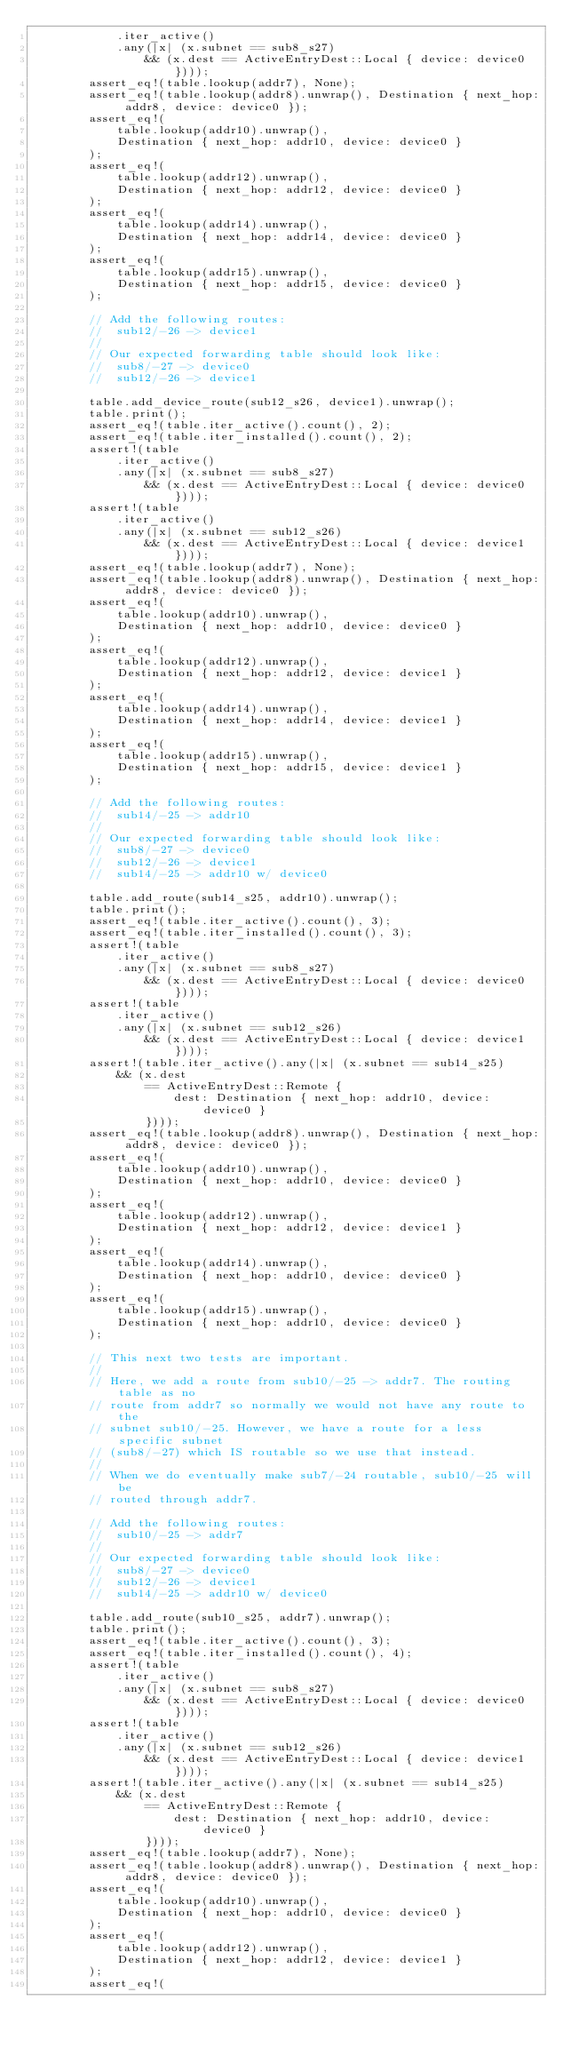Convert code to text. <code><loc_0><loc_0><loc_500><loc_500><_Rust_>            .iter_active()
            .any(|x| (x.subnet == sub8_s27)
                && (x.dest == ActiveEntryDest::Local { device: device0 })));
        assert_eq!(table.lookup(addr7), None);
        assert_eq!(table.lookup(addr8).unwrap(), Destination { next_hop: addr8, device: device0 });
        assert_eq!(
            table.lookup(addr10).unwrap(),
            Destination { next_hop: addr10, device: device0 }
        );
        assert_eq!(
            table.lookup(addr12).unwrap(),
            Destination { next_hop: addr12, device: device0 }
        );
        assert_eq!(
            table.lookup(addr14).unwrap(),
            Destination { next_hop: addr14, device: device0 }
        );
        assert_eq!(
            table.lookup(addr15).unwrap(),
            Destination { next_hop: addr15, device: device0 }
        );

        // Add the following routes:
        //  sub12/-26 -> device1
        //
        // Our expected forwarding table should look like:
        //  sub8/-27 -> device0
        //  sub12/-26 -> device1

        table.add_device_route(sub12_s26, device1).unwrap();
        table.print();
        assert_eq!(table.iter_active().count(), 2);
        assert_eq!(table.iter_installed().count(), 2);
        assert!(table
            .iter_active()
            .any(|x| (x.subnet == sub8_s27)
                && (x.dest == ActiveEntryDest::Local { device: device0 })));
        assert!(table
            .iter_active()
            .any(|x| (x.subnet == sub12_s26)
                && (x.dest == ActiveEntryDest::Local { device: device1 })));
        assert_eq!(table.lookup(addr7), None);
        assert_eq!(table.lookup(addr8).unwrap(), Destination { next_hop: addr8, device: device0 });
        assert_eq!(
            table.lookup(addr10).unwrap(),
            Destination { next_hop: addr10, device: device0 }
        );
        assert_eq!(
            table.lookup(addr12).unwrap(),
            Destination { next_hop: addr12, device: device1 }
        );
        assert_eq!(
            table.lookup(addr14).unwrap(),
            Destination { next_hop: addr14, device: device1 }
        );
        assert_eq!(
            table.lookup(addr15).unwrap(),
            Destination { next_hop: addr15, device: device1 }
        );

        // Add the following routes:
        //  sub14/-25 -> addr10
        //
        // Our expected forwarding table should look like:
        //  sub8/-27 -> device0
        //  sub12/-26 -> device1
        //  sub14/-25 -> addr10 w/ device0

        table.add_route(sub14_s25, addr10).unwrap();
        table.print();
        assert_eq!(table.iter_active().count(), 3);
        assert_eq!(table.iter_installed().count(), 3);
        assert!(table
            .iter_active()
            .any(|x| (x.subnet == sub8_s27)
                && (x.dest == ActiveEntryDest::Local { device: device0 })));
        assert!(table
            .iter_active()
            .any(|x| (x.subnet == sub12_s26)
                && (x.dest == ActiveEntryDest::Local { device: device1 })));
        assert!(table.iter_active().any(|x| (x.subnet == sub14_s25)
            && (x.dest
                == ActiveEntryDest::Remote {
                    dest: Destination { next_hop: addr10, device: device0 }
                })));
        assert_eq!(table.lookup(addr8).unwrap(), Destination { next_hop: addr8, device: device0 });
        assert_eq!(
            table.lookup(addr10).unwrap(),
            Destination { next_hop: addr10, device: device0 }
        );
        assert_eq!(
            table.lookup(addr12).unwrap(),
            Destination { next_hop: addr12, device: device1 }
        );
        assert_eq!(
            table.lookup(addr14).unwrap(),
            Destination { next_hop: addr10, device: device0 }
        );
        assert_eq!(
            table.lookup(addr15).unwrap(),
            Destination { next_hop: addr10, device: device0 }
        );

        // This next two tests are important.
        //
        // Here, we add a route from sub10/-25 -> addr7. The routing table as no
        // route from addr7 so normally we would not have any route to the
        // subnet sub10/-25. However, we have a route for a less specific subnet
        // (sub8/-27) which IS routable so we use that instead.
        //
        // When we do eventually make sub7/-24 routable, sub10/-25 will be
        // routed through addr7.

        // Add the following routes:
        //  sub10/-25 -> addr7
        //
        // Our expected forwarding table should look like:
        //  sub8/-27 -> device0
        //  sub12/-26 -> device1
        //  sub14/-25 -> addr10 w/ device0

        table.add_route(sub10_s25, addr7).unwrap();
        table.print();
        assert_eq!(table.iter_active().count(), 3);
        assert_eq!(table.iter_installed().count(), 4);
        assert!(table
            .iter_active()
            .any(|x| (x.subnet == sub8_s27)
                && (x.dest == ActiveEntryDest::Local { device: device0 })));
        assert!(table
            .iter_active()
            .any(|x| (x.subnet == sub12_s26)
                && (x.dest == ActiveEntryDest::Local { device: device1 })));
        assert!(table.iter_active().any(|x| (x.subnet == sub14_s25)
            && (x.dest
                == ActiveEntryDest::Remote {
                    dest: Destination { next_hop: addr10, device: device0 }
                })));
        assert_eq!(table.lookup(addr7), None);
        assert_eq!(table.lookup(addr8).unwrap(), Destination { next_hop: addr8, device: device0 });
        assert_eq!(
            table.lookup(addr10).unwrap(),
            Destination { next_hop: addr10, device: device0 }
        );
        assert_eq!(
            table.lookup(addr12).unwrap(),
            Destination { next_hop: addr12, device: device1 }
        );
        assert_eq!(</code> 